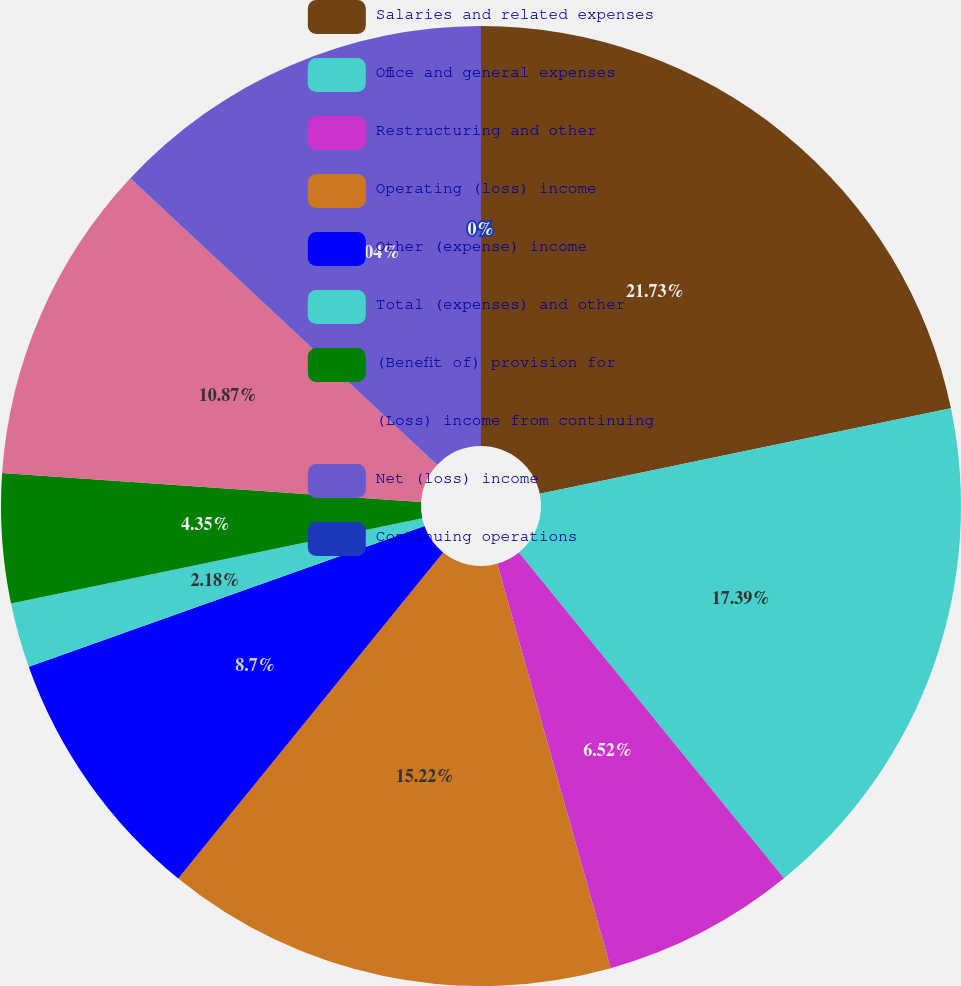Convert chart. <chart><loc_0><loc_0><loc_500><loc_500><pie_chart><fcel>Salaries and related expenses<fcel>Office and general expenses<fcel>Restructuring and other<fcel>Operating (loss) income<fcel>Other (expense) income<fcel>Total (expenses) and other<fcel>(Benefit of) provision for<fcel>(Loss) income from continuing<fcel>Net (loss) income<fcel>Continuing operations<nl><fcel>21.74%<fcel>17.39%<fcel>6.52%<fcel>15.22%<fcel>8.7%<fcel>2.18%<fcel>4.35%<fcel>10.87%<fcel>13.04%<fcel>0.0%<nl></chart> 